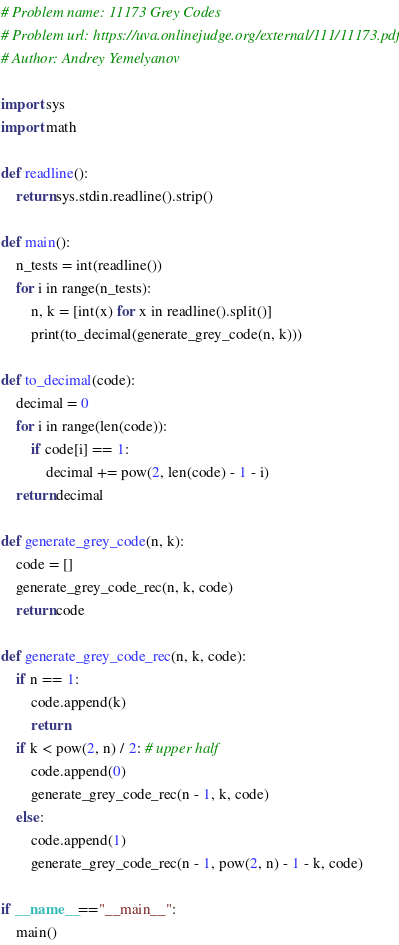<code> <loc_0><loc_0><loc_500><loc_500><_Python_># Problem name: 11173 Grey Codes
# Problem url: https://uva.onlinejudge.org/external/111/11173.pdf
# Author: Andrey Yemelyanov

import sys
import math

def readline():
	return sys.stdin.readline().strip()

def main():
	n_tests = int(readline())
	for i in range(n_tests):
		n, k = [int(x) for x in readline().split()]
		print(to_decimal(generate_grey_code(n, k)))

def to_decimal(code):
	decimal = 0
	for i in range(len(code)):
		if code[i] == 1:
			decimal += pow(2, len(code) - 1 - i)
	return decimal

def generate_grey_code(n, k):
	code = []
	generate_grey_code_rec(n, k, code)
	return code

def generate_grey_code_rec(n, k, code):
	if n == 1:
		code.append(k)
		return
	if k < pow(2, n) / 2: # upper half
		code.append(0)
		generate_grey_code_rec(n - 1, k, code)
	else:
		code.append(1)
		generate_grey_code_rec(n - 1, pow(2, n) - 1 - k, code)

if __name__=="__main__":
    main()
</code> 